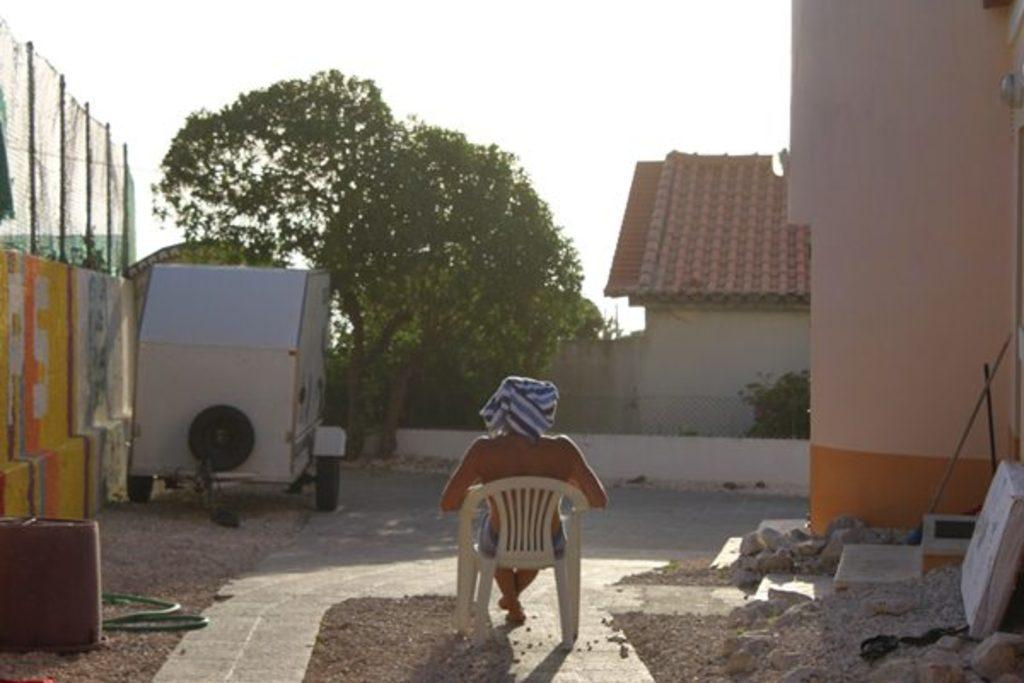What type of plant can be seen in the image? There is a tree in the image. What type of structure is visible in the image? There is a house in the image. What is the person in the image doing? The person is seated on a chair in the image. What type of barrier is present in the image? There is a metal fence on the wall in the image. What type of zebra is depicted on the canvas in the image? There is no canvas or zebra present in the image. How does the division of the house affect the person seated on the chair in the image? There is no mention of a division in the house, and the person seated on the chair is not affected by any division. 